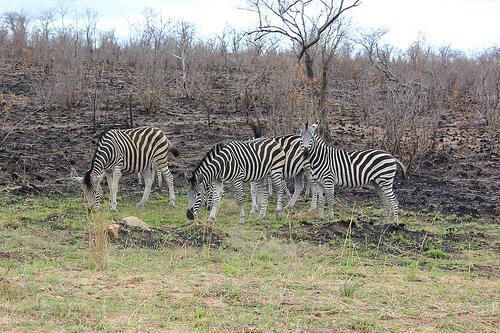How many zebras are there?
Give a very brief answer. 4. 